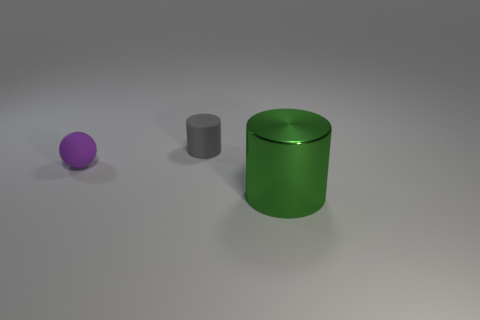Add 3 small gray rubber things. How many objects exist? 6 Subtract all cylinders. How many objects are left? 1 Subtract 0 yellow balls. How many objects are left? 3 Subtract all purple spheres. Subtract all tiny gray cylinders. How many objects are left? 1 Add 2 small purple spheres. How many small purple spheres are left? 3 Add 3 red rubber blocks. How many red rubber blocks exist? 3 